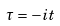Convert formula to latex. <formula><loc_0><loc_0><loc_500><loc_500>\tau = - i t</formula> 